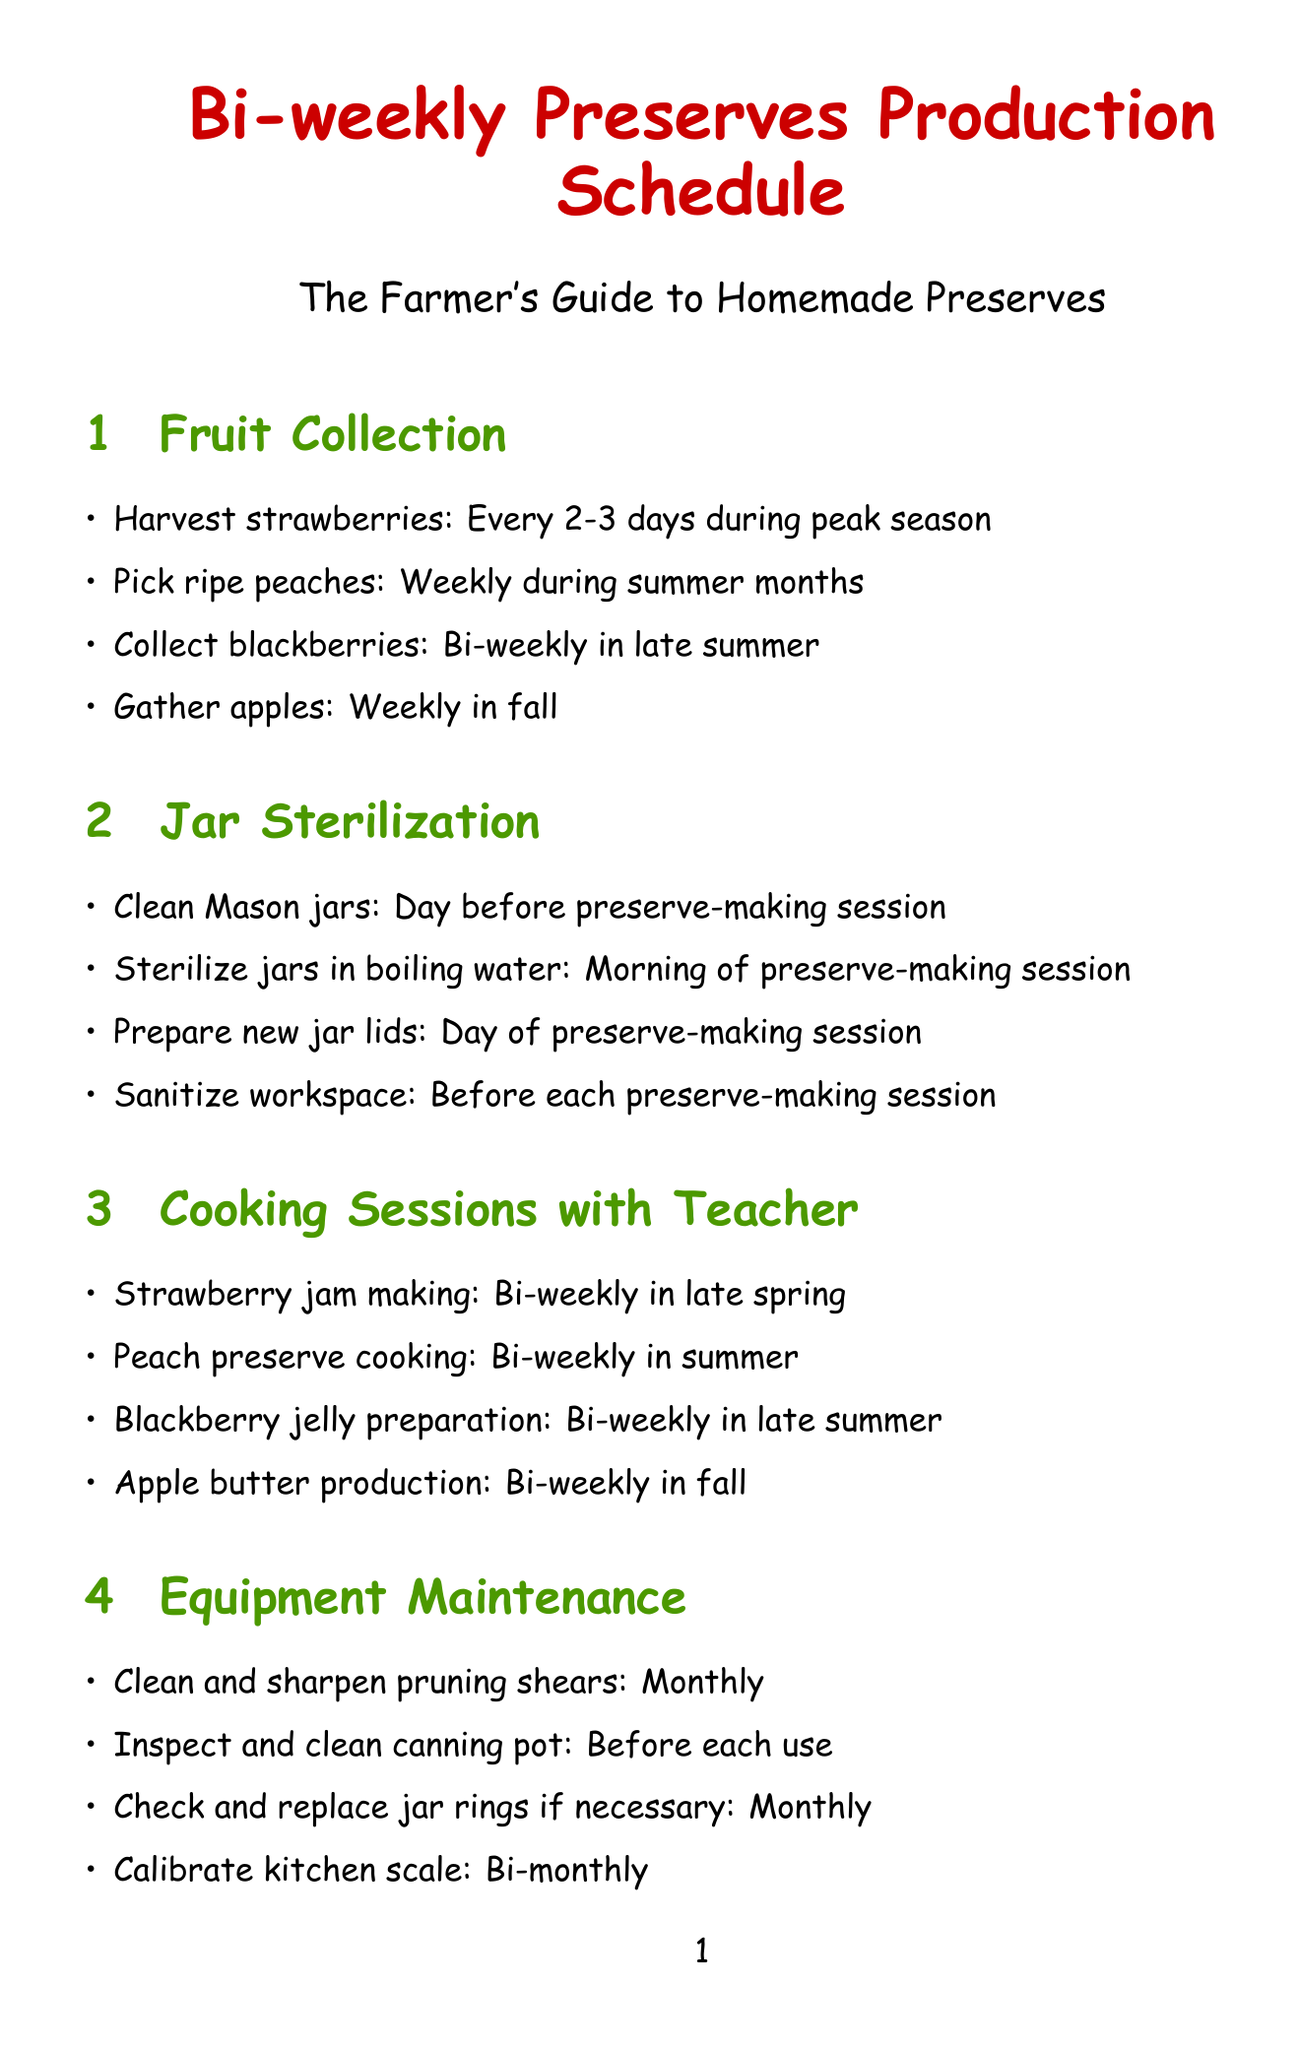What is the frequency of harvesting strawberries? The frequency for harvesting strawberries is specified as "Every 2-3 days during peak season."
Answer: Every 2-3 days What task is performed the day before preserve-making session? The document lists "Clean Mason jars" as the task to be completed the day before.
Answer: Clean Mason jars What type of preserve is made bi-weekly in late spring? According to the schedule, "Strawberry jam making" is the bi-weekly task in late spring.
Answer: Strawberry jam making When should new jar lids be prepared? The schedule states that new jar lids should be prepared "Day of preserve-making session."
Answer: Day of preserve-making session How often do equipment maintenance tasks occur? The equipment maintenance tasks are scheduled at various frequencies, including "Monthly," "Before each use," and "Bi-monthly."
Answer: Monthly, Before each use, Bi-monthly What is the frequency for checking sealed jars for proper closure? The document explains that checking sealed jars should occur "24 hours after each session."
Answer: 24 hours How often should sugar be stocked up? The schedule states that sugar should be stocked up "Bi-weekly."
Answer: Bi-weekly What is done one week after production? The document mentions that "Taste test with teacher" takes place one week after production.
Answer: Taste test with teacher 